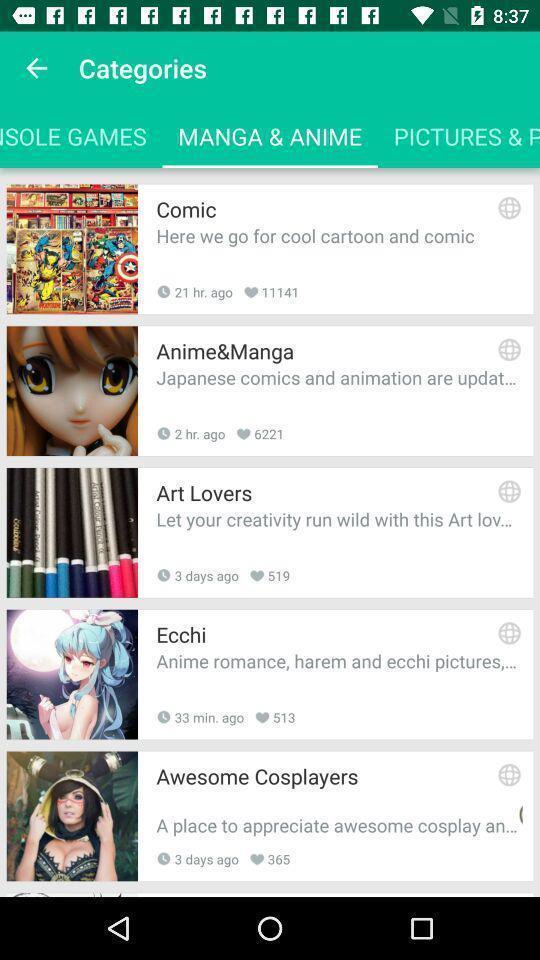Provide a textual representation of this image. Screen displaying multiple comics names with pictures. 